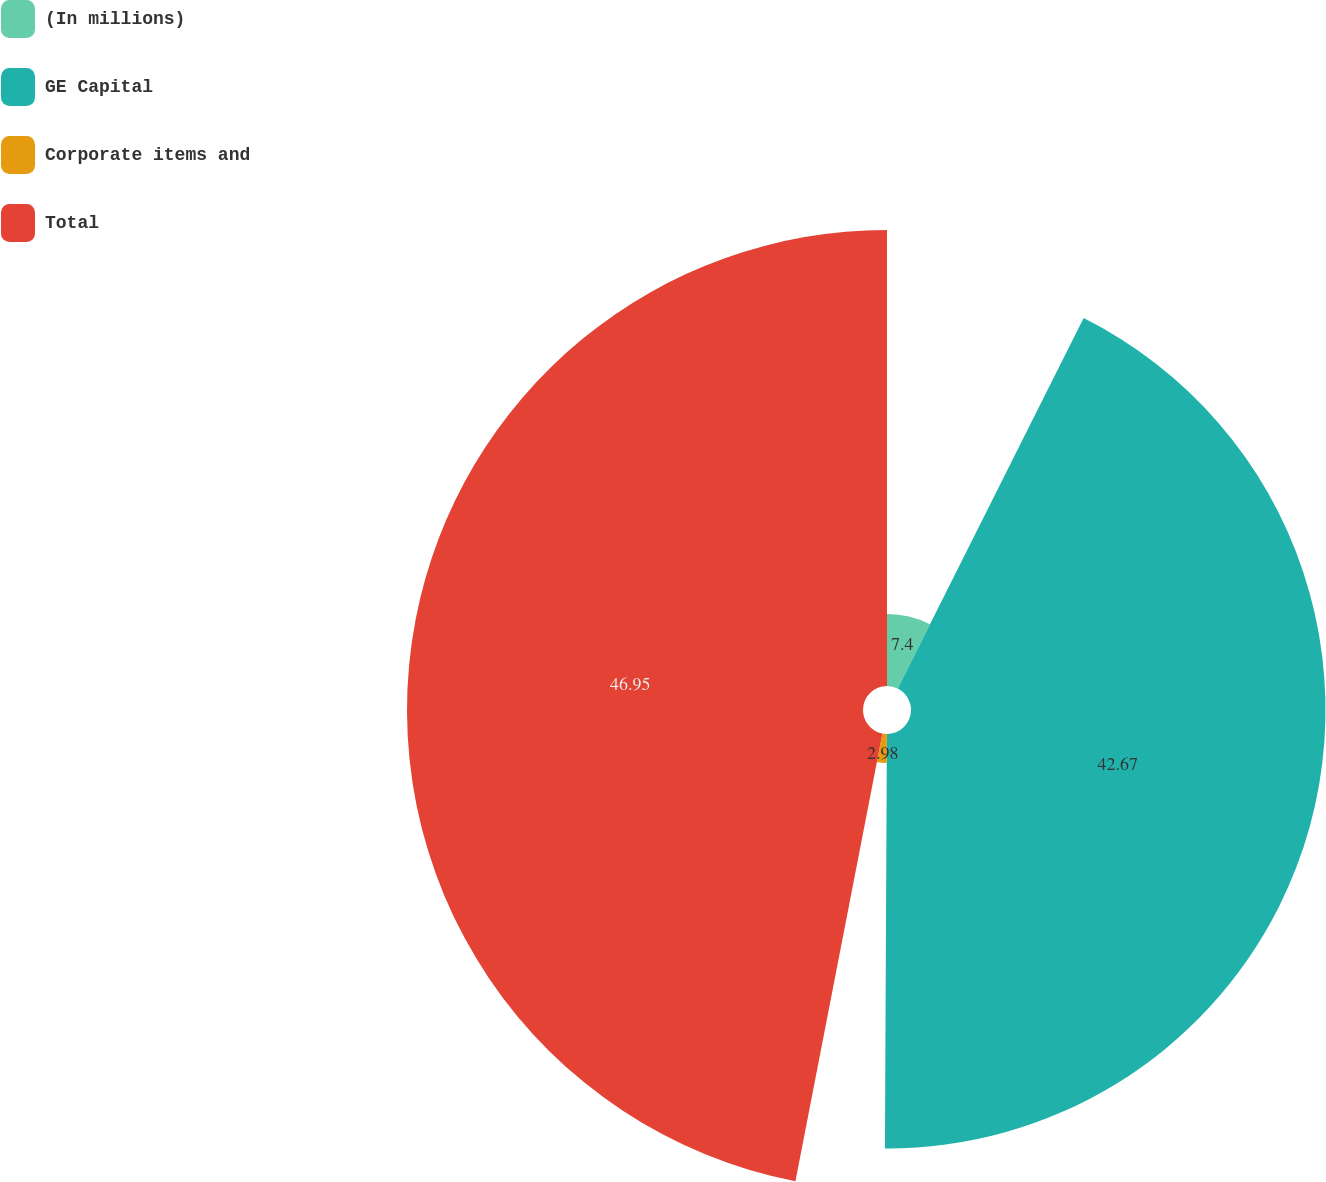Convert chart. <chart><loc_0><loc_0><loc_500><loc_500><pie_chart><fcel>(In millions)<fcel>GE Capital<fcel>Corporate items and<fcel>Total<nl><fcel>7.4%<fcel>42.67%<fcel>2.98%<fcel>46.94%<nl></chart> 